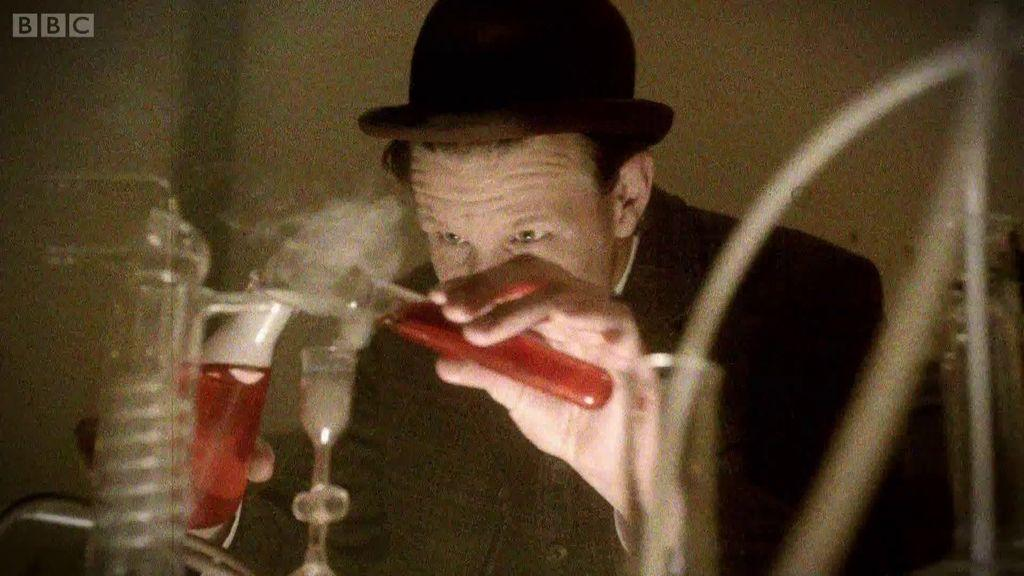What is the person in the image holding? The person is holding a glass test tube. What is the person wearing in the image? The person is wearing a black coat and a cap. What is located in front of the person? There is a jar and chemical apparatus in front of the person. What appliance is the person using to mix chemicals in the image? There is no appliance present in the image; the person is using a glass test tube and chemical apparatus. 